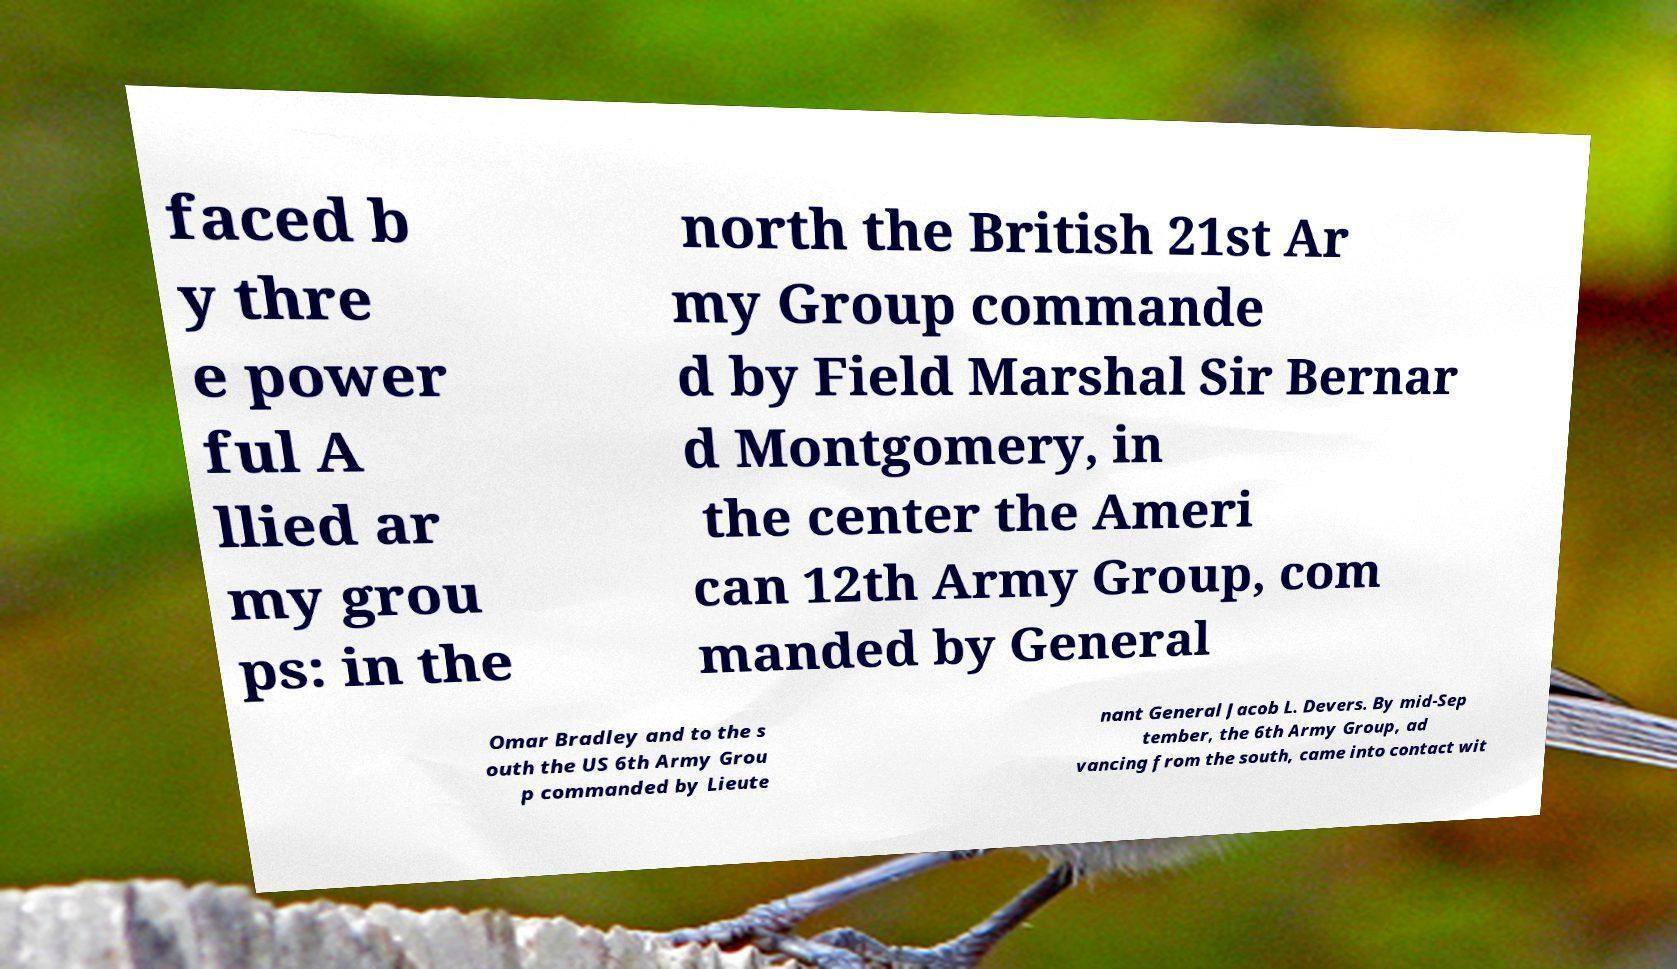Could you assist in decoding the text presented in this image and type it out clearly? faced b y thre e power ful A llied ar my grou ps: in the north the British 21st Ar my Group commande d by Field Marshal Sir Bernar d Montgomery, in the center the Ameri can 12th Army Group, com manded by General Omar Bradley and to the s outh the US 6th Army Grou p commanded by Lieute nant General Jacob L. Devers. By mid-Sep tember, the 6th Army Group, ad vancing from the south, came into contact wit 